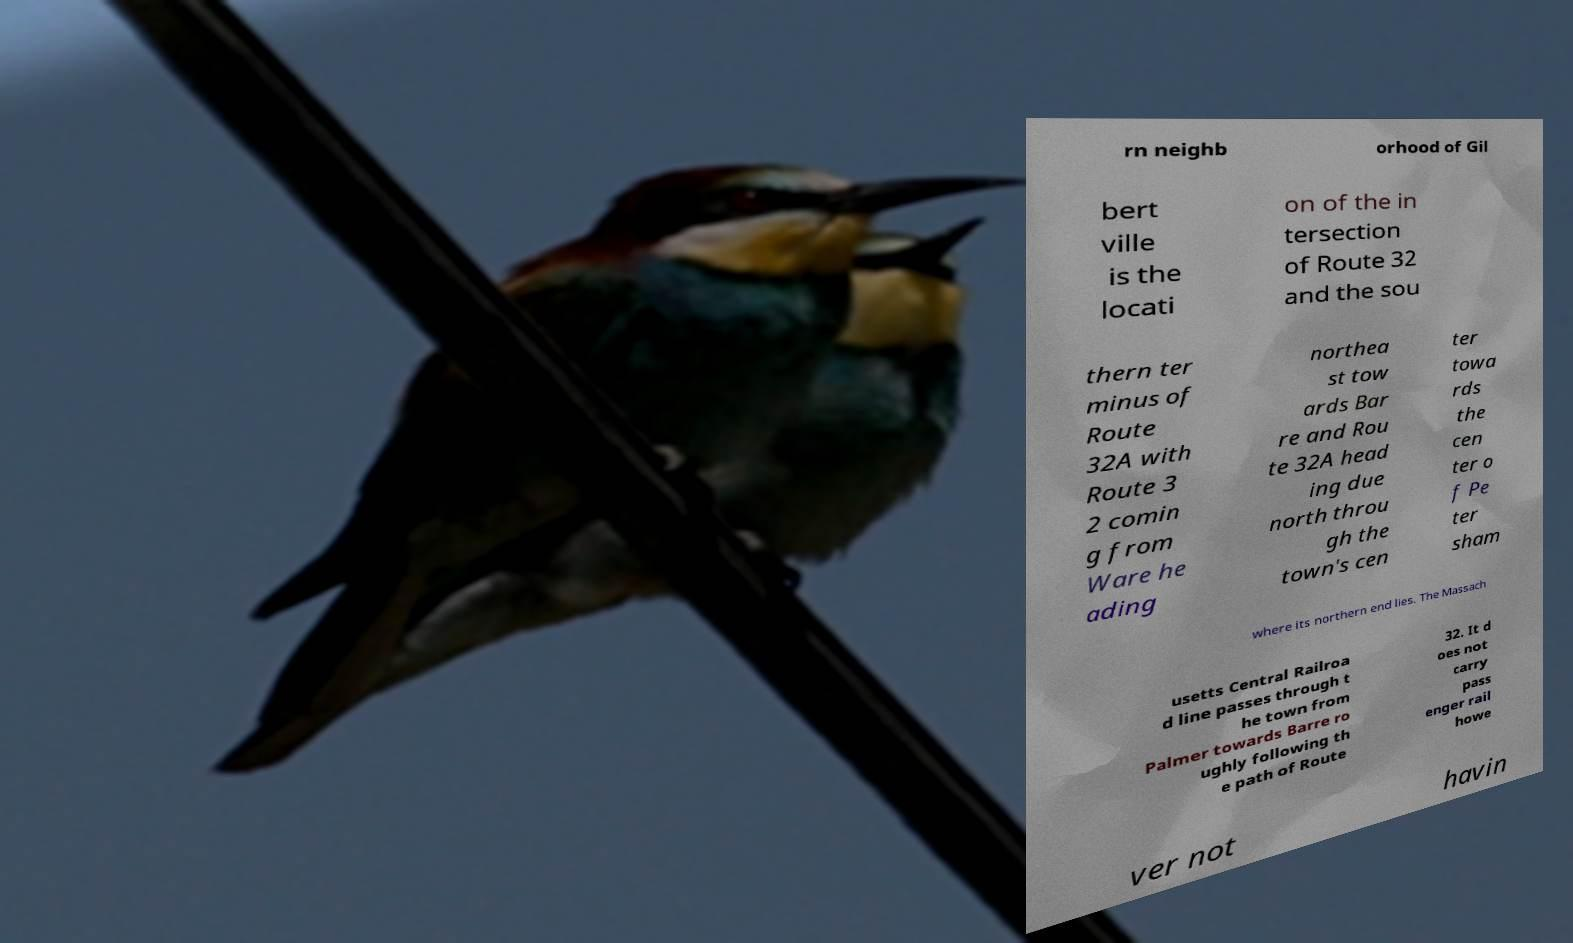Please read and relay the text visible in this image. What does it say? rn neighb orhood of Gil bert ville is the locati on of the in tersection of Route 32 and the sou thern ter minus of Route 32A with Route 3 2 comin g from Ware he ading northea st tow ards Bar re and Rou te 32A head ing due north throu gh the town's cen ter towa rds the cen ter o f Pe ter sham where its northern end lies. The Massach usetts Central Railroa d line passes through t he town from Palmer towards Barre ro ughly following th e path of Route 32. It d oes not carry pass enger rail howe ver not havin 